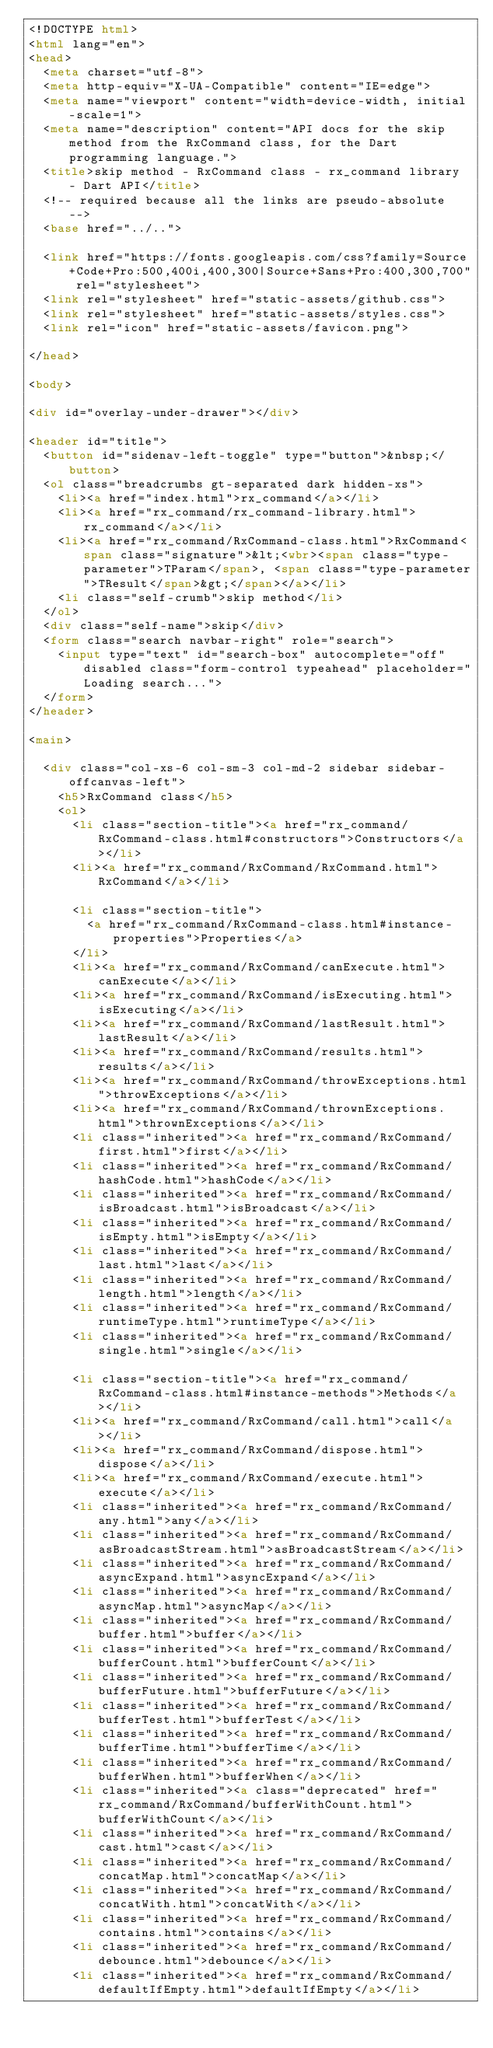<code> <loc_0><loc_0><loc_500><loc_500><_HTML_><!DOCTYPE html>
<html lang="en">
<head>
  <meta charset="utf-8">
  <meta http-equiv="X-UA-Compatible" content="IE=edge">
  <meta name="viewport" content="width=device-width, initial-scale=1">
  <meta name="description" content="API docs for the skip method from the RxCommand class, for the Dart programming language.">
  <title>skip method - RxCommand class - rx_command library - Dart API</title>
  <!-- required because all the links are pseudo-absolute -->
  <base href="../..">

  <link href="https://fonts.googleapis.com/css?family=Source+Code+Pro:500,400i,400,300|Source+Sans+Pro:400,300,700" rel="stylesheet">
  <link rel="stylesheet" href="static-assets/github.css">
  <link rel="stylesheet" href="static-assets/styles.css">
  <link rel="icon" href="static-assets/favicon.png">

</head>

<body>

<div id="overlay-under-drawer"></div>

<header id="title">
  <button id="sidenav-left-toggle" type="button">&nbsp;</button>
  <ol class="breadcrumbs gt-separated dark hidden-xs">
    <li><a href="index.html">rx_command</a></li>
    <li><a href="rx_command/rx_command-library.html">rx_command</a></li>
    <li><a href="rx_command/RxCommand-class.html">RxCommand<span class="signature">&lt;<wbr><span class="type-parameter">TParam</span>, <span class="type-parameter">TResult</span>&gt;</span></a></li>
    <li class="self-crumb">skip method</li>
  </ol>
  <div class="self-name">skip</div>
  <form class="search navbar-right" role="search">
    <input type="text" id="search-box" autocomplete="off" disabled class="form-control typeahead" placeholder="Loading search...">
  </form>
</header>

<main>

  <div class="col-xs-6 col-sm-3 col-md-2 sidebar sidebar-offcanvas-left">
    <h5>RxCommand class</h5>
    <ol>
      <li class="section-title"><a href="rx_command/RxCommand-class.html#constructors">Constructors</a></li>
      <li><a href="rx_command/RxCommand/RxCommand.html">RxCommand</a></li>
    
      <li class="section-title">
        <a href="rx_command/RxCommand-class.html#instance-properties">Properties</a>
      </li>
      <li><a href="rx_command/RxCommand/canExecute.html">canExecute</a></li>
      <li><a href="rx_command/RxCommand/isExecuting.html">isExecuting</a></li>
      <li><a href="rx_command/RxCommand/lastResult.html">lastResult</a></li>
      <li><a href="rx_command/RxCommand/results.html">results</a></li>
      <li><a href="rx_command/RxCommand/throwExceptions.html">throwExceptions</a></li>
      <li><a href="rx_command/RxCommand/thrownExceptions.html">thrownExceptions</a></li>
      <li class="inherited"><a href="rx_command/RxCommand/first.html">first</a></li>
      <li class="inherited"><a href="rx_command/RxCommand/hashCode.html">hashCode</a></li>
      <li class="inherited"><a href="rx_command/RxCommand/isBroadcast.html">isBroadcast</a></li>
      <li class="inherited"><a href="rx_command/RxCommand/isEmpty.html">isEmpty</a></li>
      <li class="inherited"><a href="rx_command/RxCommand/last.html">last</a></li>
      <li class="inherited"><a href="rx_command/RxCommand/length.html">length</a></li>
      <li class="inherited"><a href="rx_command/RxCommand/runtimeType.html">runtimeType</a></li>
      <li class="inherited"><a href="rx_command/RxCommand/single.html">single</a></li>
    
      <li class="section-title"><a href="rx_command/RxCommand-class.html#instance-methods">Methods</a></li>
      <li><a href="rx_command/RxCommand/call.html">call</a></li>
      <li><a href="rx_command/RxCommand/dispose.html">dispose</a></li>
      <li><a href="rx_command/RxCommand/execute.html">execute</a></li>
      <li class="inherited"><a href="rx_command/RxCommand/any.html">any</a></li>
      <li class="inherited"><a href="rx_command/RxCommand/asBroadcastStream.html">asBroadcastStream</a></li>
      <li class="inherited"><a href="rx_command/RxCommand/asyncExpand.html">asyncExpand</a></li>
      <li class="inherited"><a href="rx_command/RxCommand/asyncMap.html">asyncMap</a></li>
      <li class="inherited"><a href="rx_command/RxCommand/buffer.html">buffer</a></li>
      <li class="inherited"><a href="rx_command/RxCommand/bufferCount.html">bufferCount</a></li>
      <li class="inherited"><a href="rx_command/RxCommand/bufferFuture.html">bufferFuture</a></li>
      <li class="inherited"><a href="rx_command/RxCommand/bufferTest.html">bufferTest</a></li>
      <li class="inherited"><a href="rx_command/RxCommand/bufferTime.html">bufferTime</a></li>
      <li class="inherited"><a href="rx_command/RxCommand/bufferWhen.html">bufferWhen</a></li>
      <li class="inherited"><a class="deprecated" href="rx_command/RxCommand/bufferWithCount.html">bufferWithCount</a></li>
      <li class="inherited"><a href="rx_command/RxCommand/cast.html">cast</a></li>
      <li class="inherited"><a href="rx_command/RxCommand/concatMap.html">concatMap</a></li>
      <li class="inherited"><a href="rx_command/RxCommand/concatWith.html">concatWith</a></li>
      <li class="inherited"><a href="rx_command/RxCommand/contains.html">contains</a></li>
      <li class="inherited"><a href="rx_command/RxCommand/debounce.html">debounce</a></li>
      <li class="inherited"><a href="rx_command/RxCommand/defaultIfEmpty.html">defaultIfEmpty</a></li></code> 